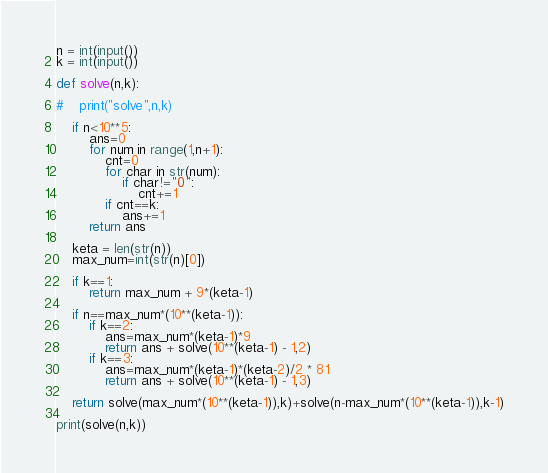<code> <loc_0><loc_0><loc_500><loc_500><_Python_>n = int(input())
k = int(input())

def solve(n,k):

#    print("solve",n,k)

    if n<10**5:
        ans=0
        for num in range(1,n+1):
            cnt=0
            for char in str(num):
                if char!="0":
                    cnt+=1
            if cnt==k:
                ans+=1
        return ans

    keta = len(str(n))
    max_num=int(str(n)[0])

    if k==1:
        return max_num + 9*(keta-1)

    if n==max_num*(10**(keta-1)):
        if k==2:
            ans=max_num*(keta-1)*9
            return ans + solve(10**(keta-1) - 1,2)
        if k==3:
            ans=max_num*(keta-1)*(keta-2)/2 * 81
            return ans + solve(10**(keta-1) - 1,3)

    return solve(max_num*(10**(keta-1)),k)+solve(n-max_num*(10**(keta-1)),k-1)

print(solve(n,k))</code> 